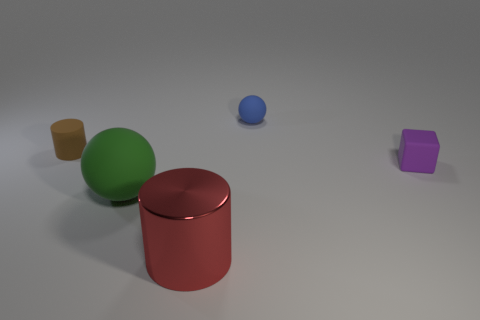Is the size of the red shiny cylinder the same as the matte cube?
Your response must be concise. No. There is a object that is both behind the green object and on the left side of the large shiny cylinder; what size is it?
Offer a terse response. Small. What number of matte objects are blocks or big balls?
Give a very brief answer. 2. Are there more purple matte objects on the left side of the tiny matte cylinder than green balls?
Offer a very short reply. No. There is a cylinder behind the red shiny cylinder; what material is it?
Provide a short and direct response. Rubber. What number of red cylinders have the same material as the blue sphere?
Ensure brevity in your answer.  0. There is a thing that is behind the green rubber ball and left of the red metallic object; what shape is it?
Make the answer very short. Cylinder. What number of things are either rubber balls that are behind the tiny brown thing or tiny matte things to the right of the blue thing?
Provide a short and direct response. 2. Is the number of blue rubber spheres in front of the small brown object the same as the number of large things behind the red shiny cylinder?
Offer a terse response. No. What shape is the tiny thing behind the cylinder behind the big metallic thing?
Provide a succinct answer. Sphere. 